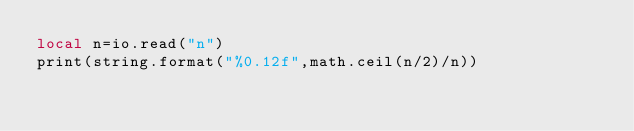<code> <loc_0><loc_0><loc_500><loc_500><_Lua_>local n=io.read("n")
print(string.format("%0.12f",math.ceil(n/2)/n))</code> 